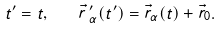Convert formula to latex. <formula><loc_0><loc_0><loc_500><loc_500>t ^ { \prime } = t , \quad \vec { r } \, ^ { \prime } _ { \alpha } ( t ^ { \prime } ) = \vec { r } _ { \alpha } ( t ) + \vec { r } _ { 0 } .</formula> 